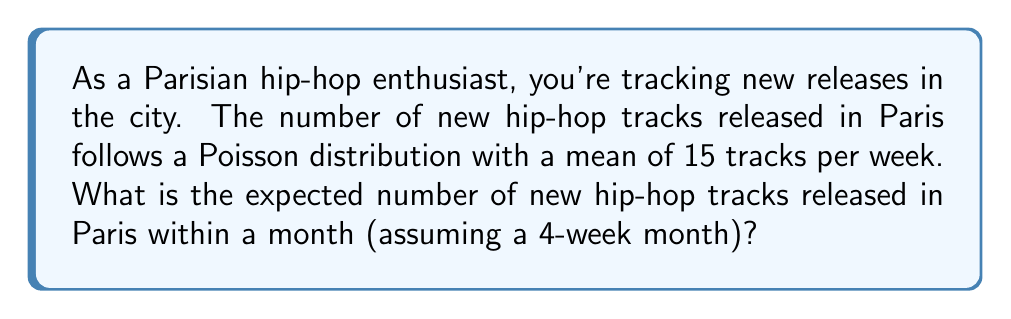Give your solution to this math problem. Let's approach this step-by-step:

1) We're given that the number of new hip-hop tracks released per week follows a Poisson distribution with a mean of 15.

2) For a Poisson distribution, the expected value (E[X]) is equal to its parameter λ. So, E[X] = 15 tracks per week.

3) We want to find the expected number of tracks for a month, which is defined as 4 weeks in this problem.

4) The Poisson distribution has an additive property: if X and Y are independent Poisson random variables with means λ₁ and λ₂ respectively, then X + Y follows a Poisson distribution with mean λ₁ + λ₂.

5) Therefore, for 4 independent weeks, we can add the expected values:

   E[Month] = E[Week 1] + E[Week 2] + E[Week 3] + E[Week 4]
             = 15 + 15 + 15 + 15
             = 4 * 15
             = 60

Thus, the expected number of new hip-hop tracks released in Paris within a month is 60.
Answer: 60 tracks 